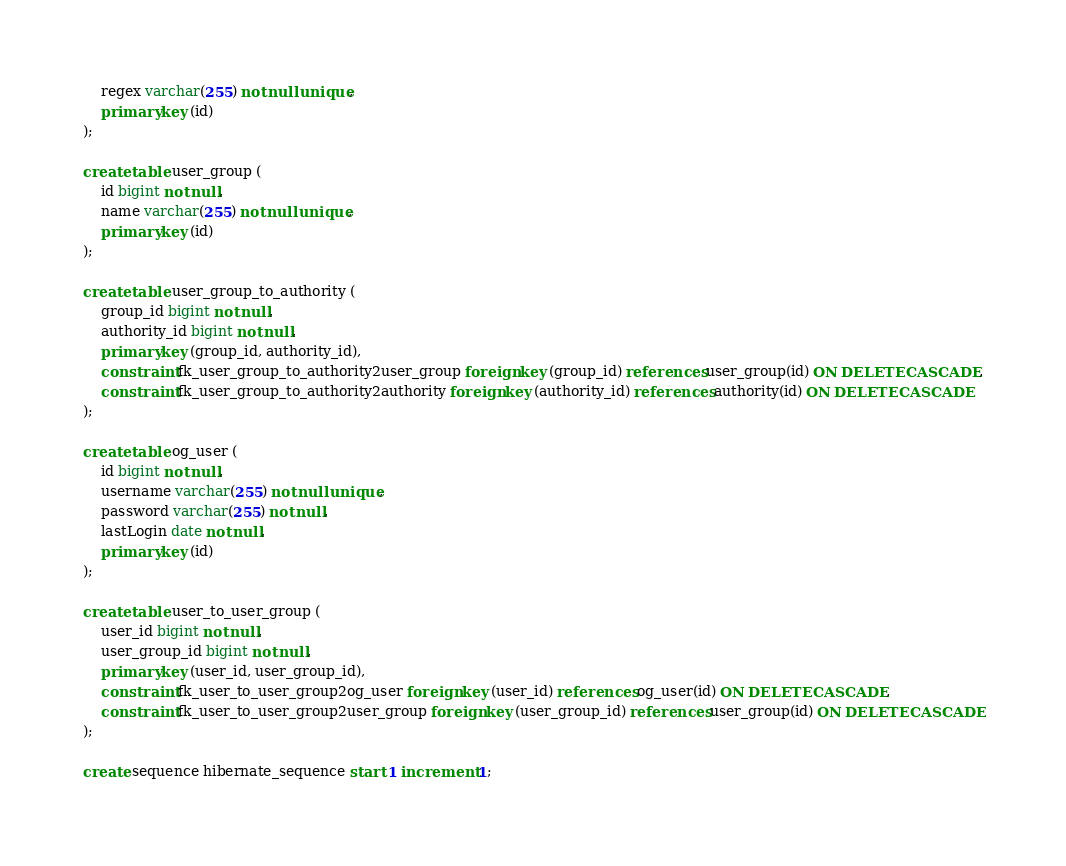<code> <loc_0><loc_0><loc_500><loc_500><_SQL_>    regex varchar(255) not null unique,
    primary key (id)
);

create table user_group (
    id bigint not null,
    name varchar(255) not null unique,
    primary key (id)
);

create table user_group_to_authority (
    group_id bigint not null,
    authority_id bigint not null,
    primary key (group_id, authority_id),
    constraint fk_user_group_to_authority2user_group foreign key (group_id) references user_group(id) ON DELETE CASCADE,
    constraint fk_user_group_to_authority2authority foreign key (authority_id) references authority(id) ON DELETE CASCADE
);

create table og_user (
    id bigint not null,
    username varchar(255) not null unique,
    password varchar(255) not null,
    lastLogin date not null,
    primary key (id)
);

create table user_to_user_group (
    user_id bigint not null,
    user_group_id bigint not null,
    primary key (user_id, user_group_id),
    constraint fk_user_to_user_group2og_user foreign key (user_id) references og_user(id) ON DELETE CASCADE,
    constraint fk_user_to_user_group2user_group foreign key (user_group_id) references user_group(id) ON DELETE CASCADE
);

create sequence hibernate_sequence start 1 increment 1;
</code> 